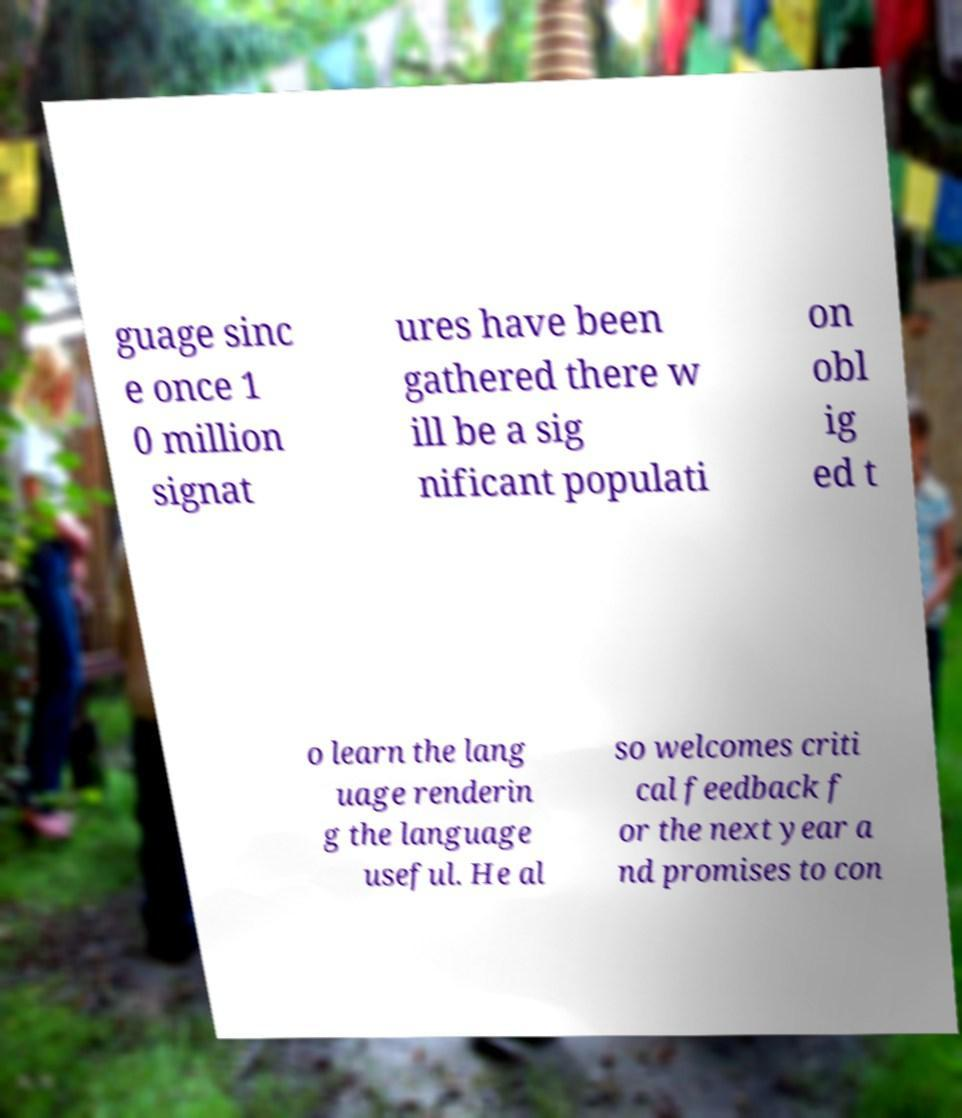There's text embedded in this image that I need extracted. Can you transcribe it verbatim? guage sinc e once 1 0 million signat ures have been gathered there w ill be a sig nificant populati on obl ig ed t o learn the lang uage renderin g the language useful. He al so welcomes criti cal feedback f or the next year a nd promises to con 